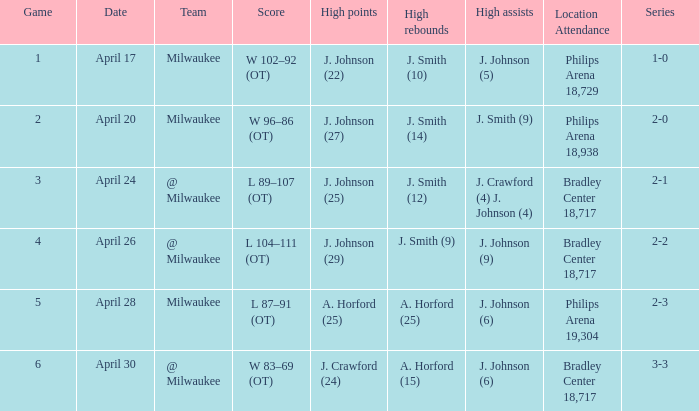What was the quantity of rebounds in game 2? J. Smith (14). 